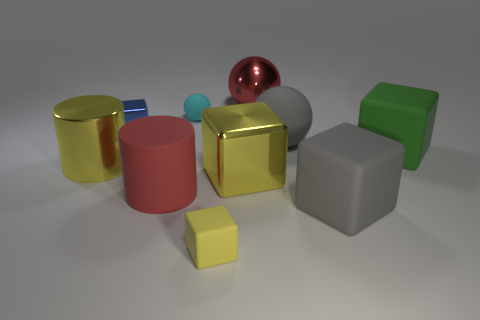Subtract all brown balls. How many yellow cubes are left? 2 Subtract all big spheres. How many spheres are left? 1 Subtract 1 cubes. How many cubes are left? 4 Subtract all blue blocks. How many blocks are left? 4 Subtract all cylinders. How many objects are left? 8 Subtract all green balls. Subtract all blue cubes. How many balls are left? 3 Add 4 red balls. How many red balls exist? 5 Subtract 0 purple spheres. How many objects are left? 10 Subtract all small purple cylinders. Subtract all shiny balls. How many objects are left? 9 Add 5 small cyan matte balls. How many small cyan matte balls are left? 6 